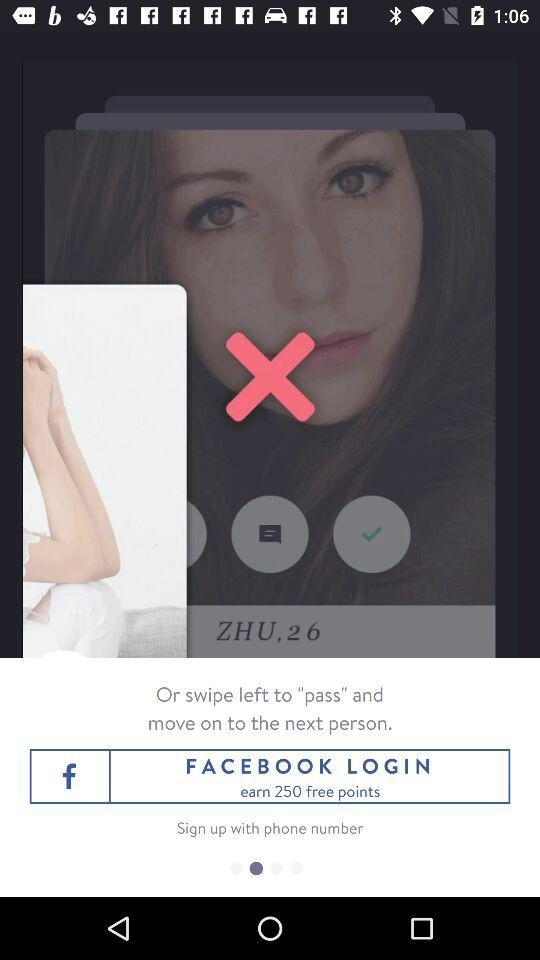What application is used to log in? The application used to log in is "FACEBOOK". 